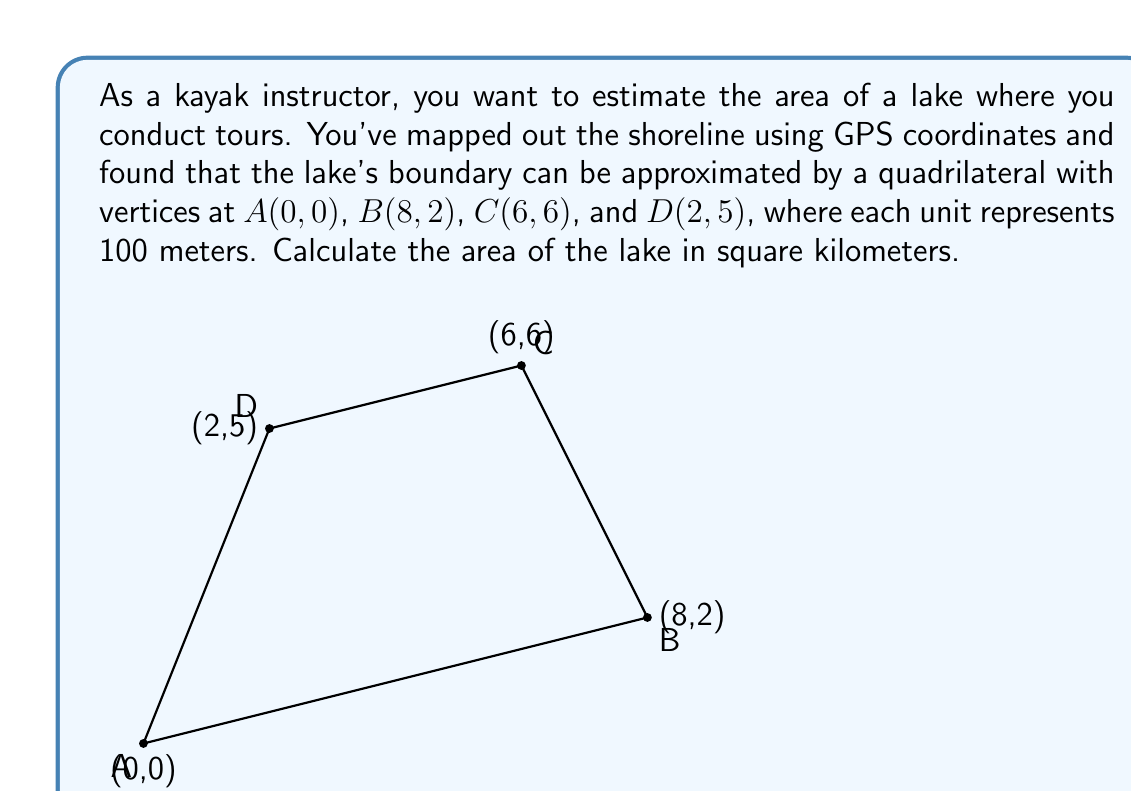Could you help me with this problem? To solve this problem, we'll use the shoelace formula (also known as the surveyor's formula) to calculate the area of the quadrilateral. The steps are as follows:

1) The shoelace formula for a quadrilateral with vertices $(x_1, y_1)$, $(x_2, y_2)$, $(x_3, y_3)$, and $(x_4, y_4)$ is:

   $$Area = \frac{1}{2}|(x_1y_2 + x_2y_3 + x_3y_4 + x_4y_1) - (y_1x_2 + y_2x_3 + y_3x_4 + y_4x_1)|$$

2) Substituting our coordinates:
   $A(0, 0)$, $B(8, 2)$, $C(6, 6)$, $D(2, 5)$

   $$Area = \frac{1}{2}|(0 \cdot 2 + 8 \cdot 6 + 6 \cdot 5 + 2 \cdot 0) - (0 \cdot 8 + 2 \cdot 6 + 6 \cdot 2 + 5 \cdot 0)|$$

3) Simplifying:
   $$Area = \frac{1}{2}|(0 + 48 + 30 + 0) - (0 + 12 + 12 + 0)|$$
   $$Area = \frac{1}{2}|78 - 24|$$
   $$Area = \frac{1}{2}|54|$$
   $$Area = 27$$

4) Remember that each unit represents 100 meters, so the area is actually 27 * 100^2 = 270,000 square meters.

5) Convert to square kilometers:
   $$270,000 \text{ m}^2 = 0.27 \text{ km}^2$$
Answer: The area of the lake is 0.27 square kilometers. 